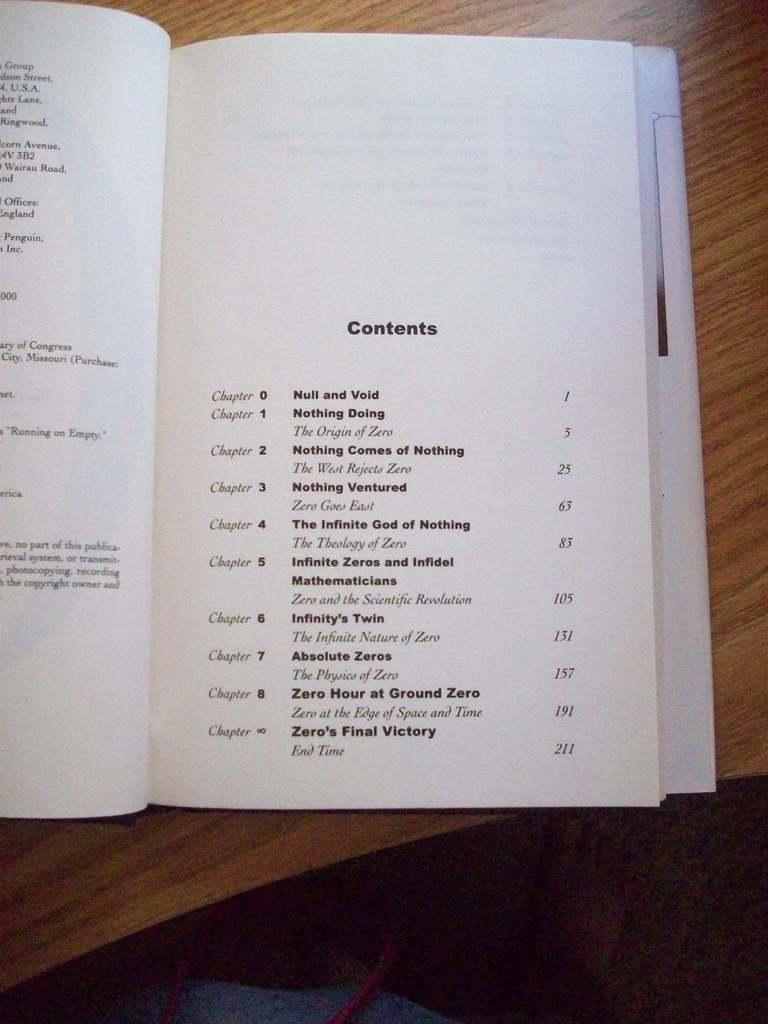What object can be seen in the image? There is a book in the image. Where is the book located? The book is on a wooden table. What can be observed on the book? There is writing on the book. How many eyes can be seen on the book in the image? There are no eyes present on the book in the image. 